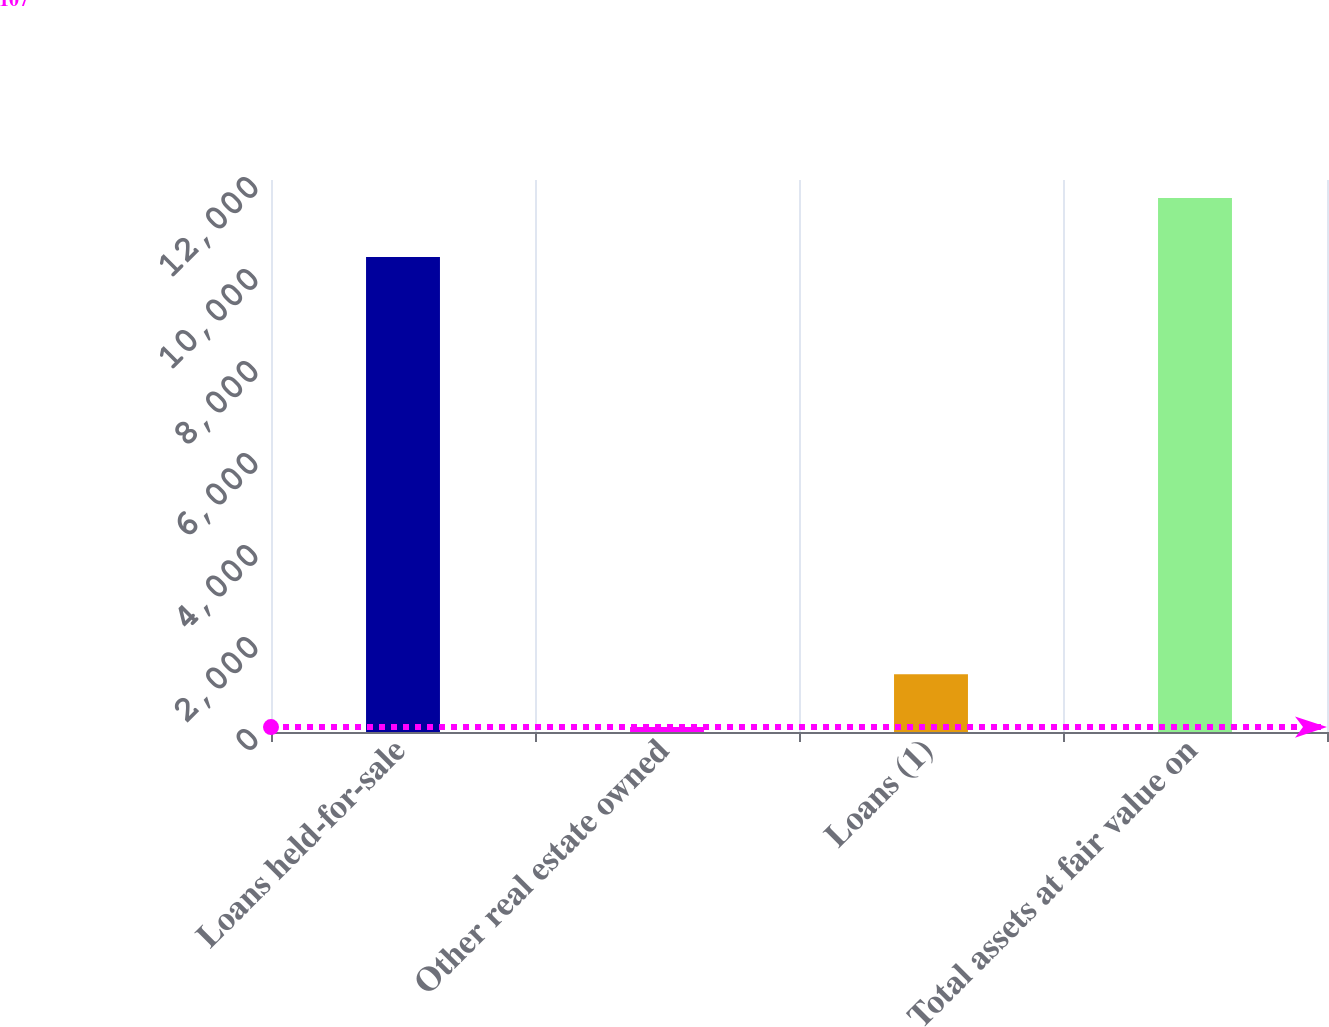Convert chart to OTSL. <chart><loc_0><loc_0><loc_500><loc_500><bar_chart><fcel>Loans held-for-sale<fcel>Other real estate owned<fcel>Loans (1)<fcel>Total assets at fair value on<nl><fcel>10326<fcel>107<fcel>1256.9<fcel>11606<nl></chart> 